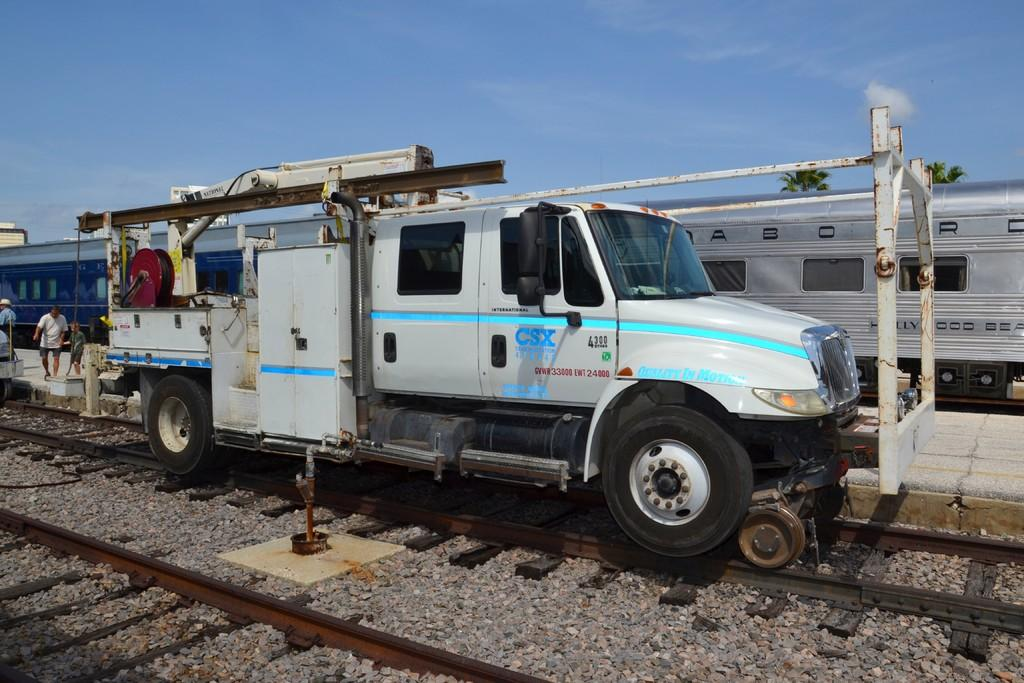What is the main subject of the image? The main subject of the image is a van on a railway track. What is located behind the van? A train is visible behind the van. What is the color of the sky in the image? The sky is blue in the image. Where are the people in the image located? People are standing on a platform on the left side of the image. How many chairs are visible in the image? There are no chairs present in the image. What type of body is visible in the image? There is no body present in the image; it features a van, a train, and people on a platform. 